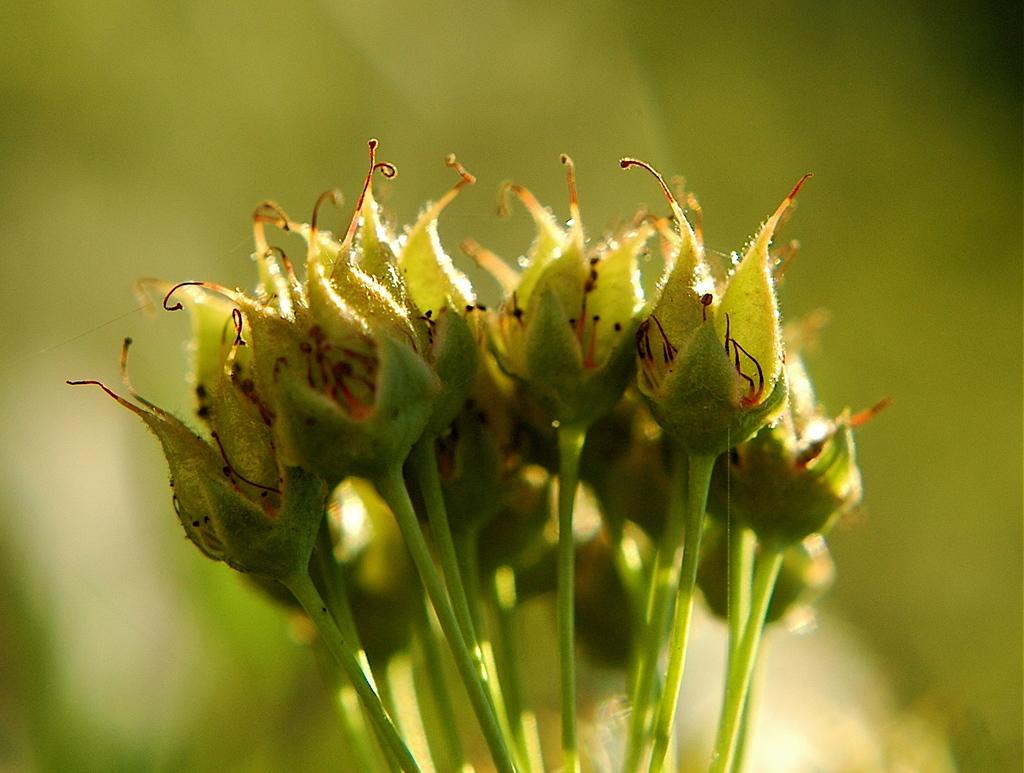What is located in the front of the image? There are flowers in the front of the image. Can you describe the background of the image? The background of the image is blurry. How many fangs can be seen in the image? There are no fangs present in the image. What type of earthquake is depicted in the image? There is no earthquake depicted in the image; it features flowers in the front and a blurry background. 